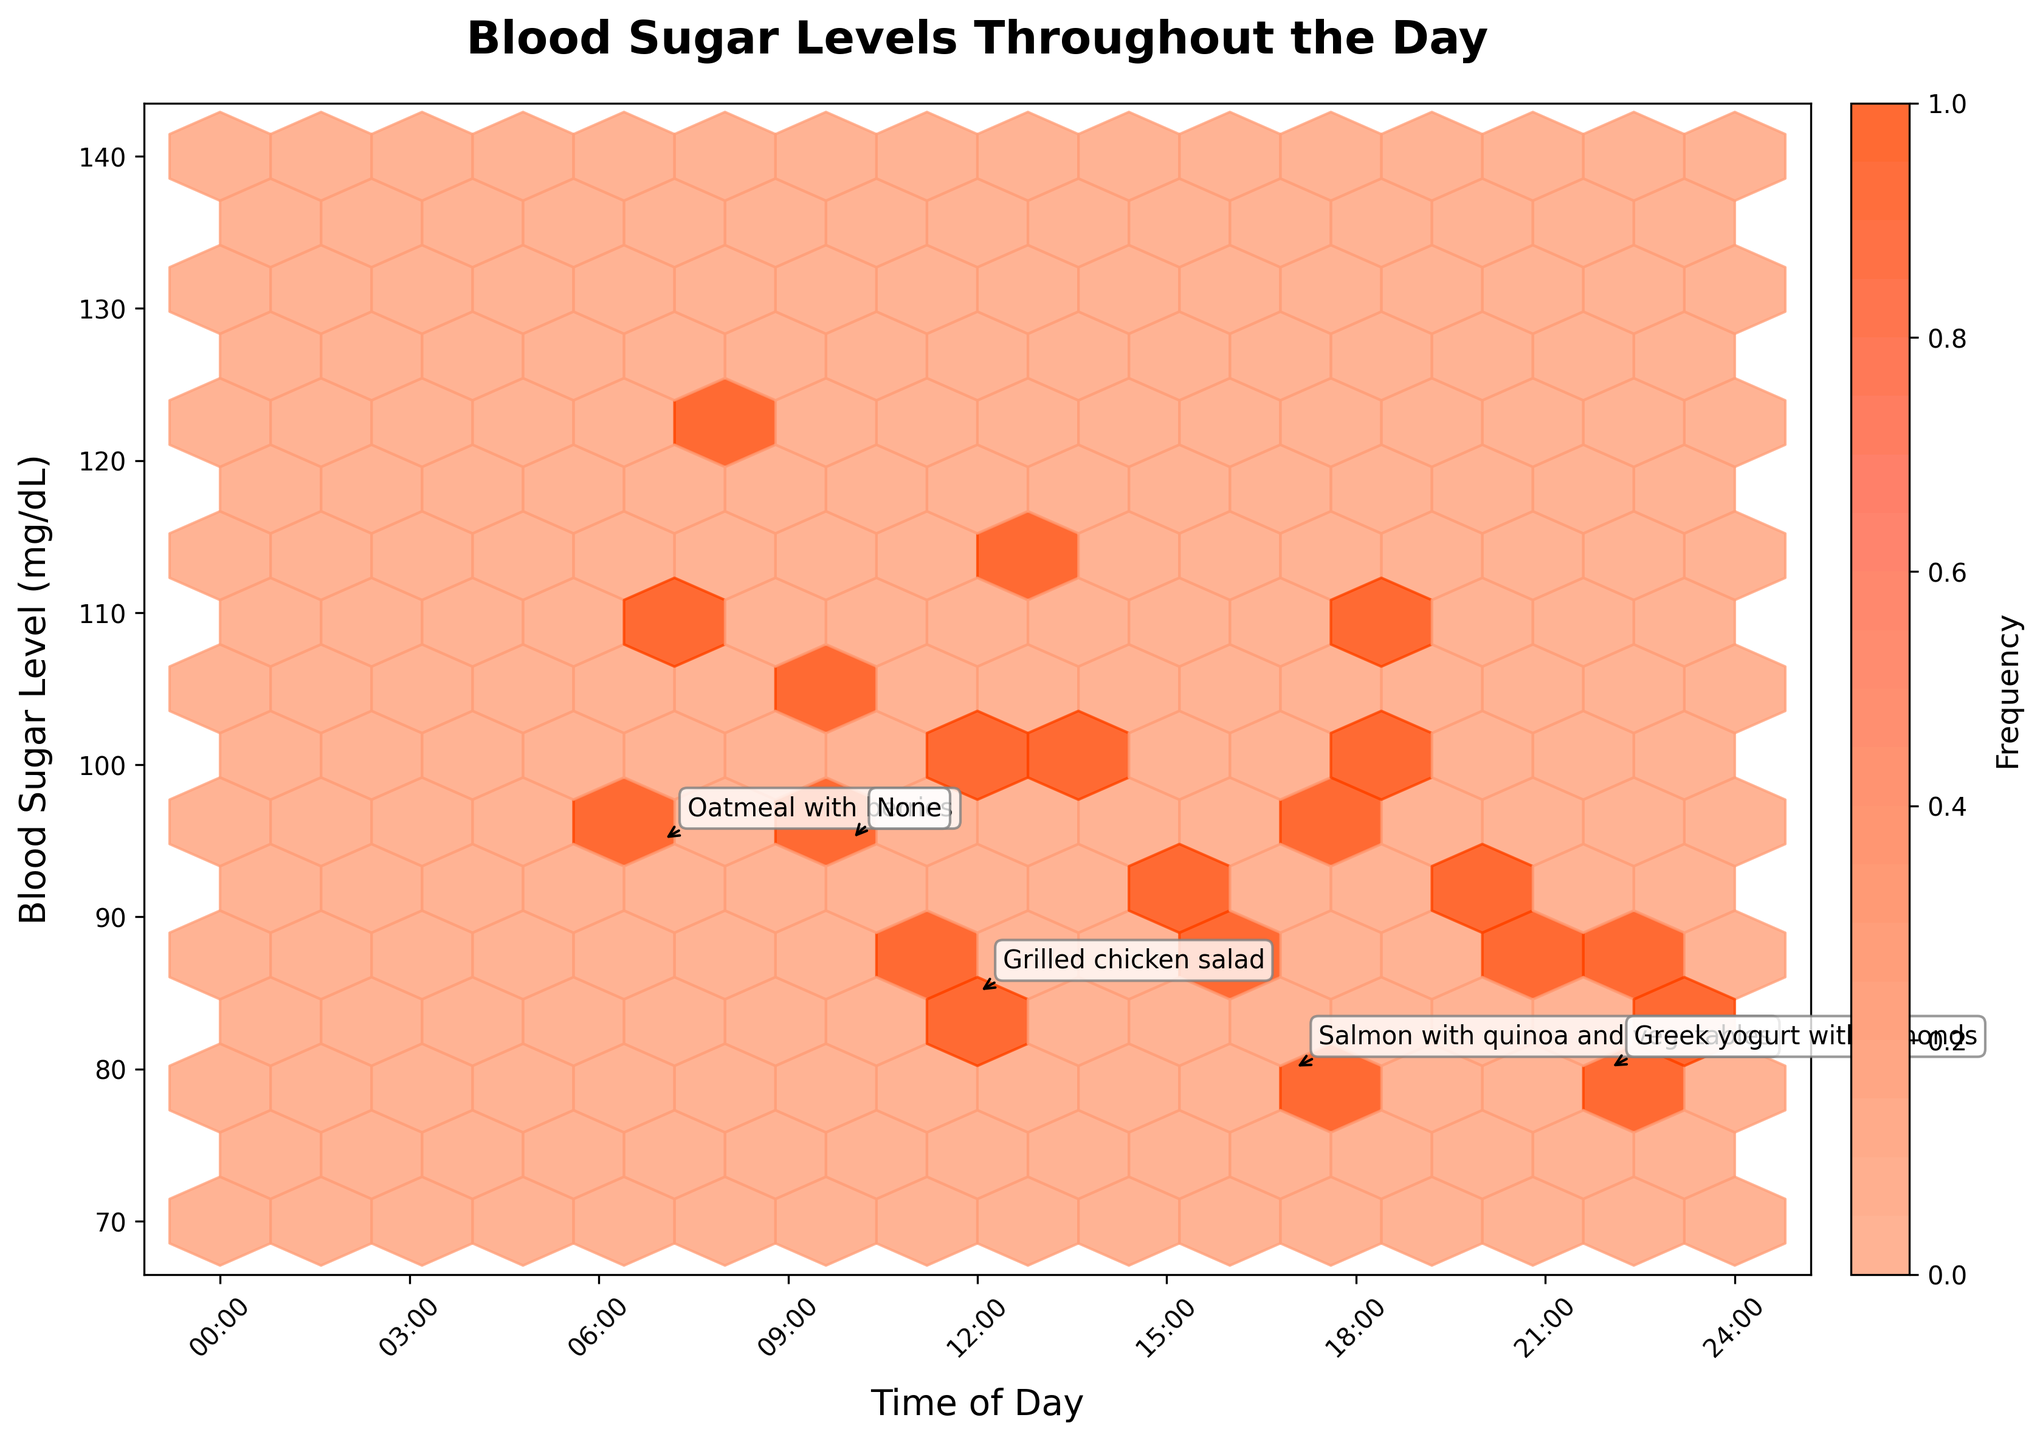What is the title of the plot? The title can usually be found centered at the top of the plot in a larger or bold font. In this case, the title is "Blood Sugar Levels Throughout the Day."
Answer: Blood Sugar Levels Throughout the Day What time blocks represent the highest blood sugar levels? To identify the highest blood sugar levels, look for the densest orange or red hexagons along the y-axis (Blood Sugar Level) and then track back to the x-axis (Time of Day). The hexagons around 8:00 AM and 6:00 PM seem to have the highest concentrations.
Answer: Around 8:00 AM and 6:00 PM Which meal shows a noticeable drop in blood sugar after consumption? Look at annotated meal times and follow the trend of Blood Sugar levels after the meal. "Grilled chicken salad" at 1:00 PM shows a decrease in Blood Sugar levels in subsequent time points.
Answer: Grilled chicken salad How does the frequency of blood sugar levels change throughout the day? Observe the different shades in the hexagons from left to right across the plot. More frequent readings are indicated by darker hexagons, found commonly around morning and early evening times.
Answer: More frequent in the morning and evening Which meal composition corresponds to the lowest blood sugar level recorded? Find the lowest y-axis values and check the annotated meal nearby. The annotation for "Greek yogurt with almonds" close to 10:00 PM shows lower blood sugar values.
Answer: Greek yogurt with almonds What time of day generally has the lowest blood sugar levels based on the plot? Focus on the time axis and look for where the overall values are at their lowest. Late evening before midnight seems to have the lowest levels.
Answer: Late evening Are there any time periods without a meal that show fluctuations in blood sugar? Check the regions labeled "None" and examine if there are any variations in the Blood Sugar levels. At around 10:00 AM and 3:00 PM, fluctuations in levels without an annotated meal can be seen.
Answer: 10:00 AM and 3:00 PM Between which times is there the most stability in blood sugar levels? Look for horizontal clusters of similarly colored hexagons, indicating consistent Blood Sugar levels. Between 10:00 PM and 1:00 AM shows a stable trend.
Answer: Between 10:00 PM and 1:00 AM 